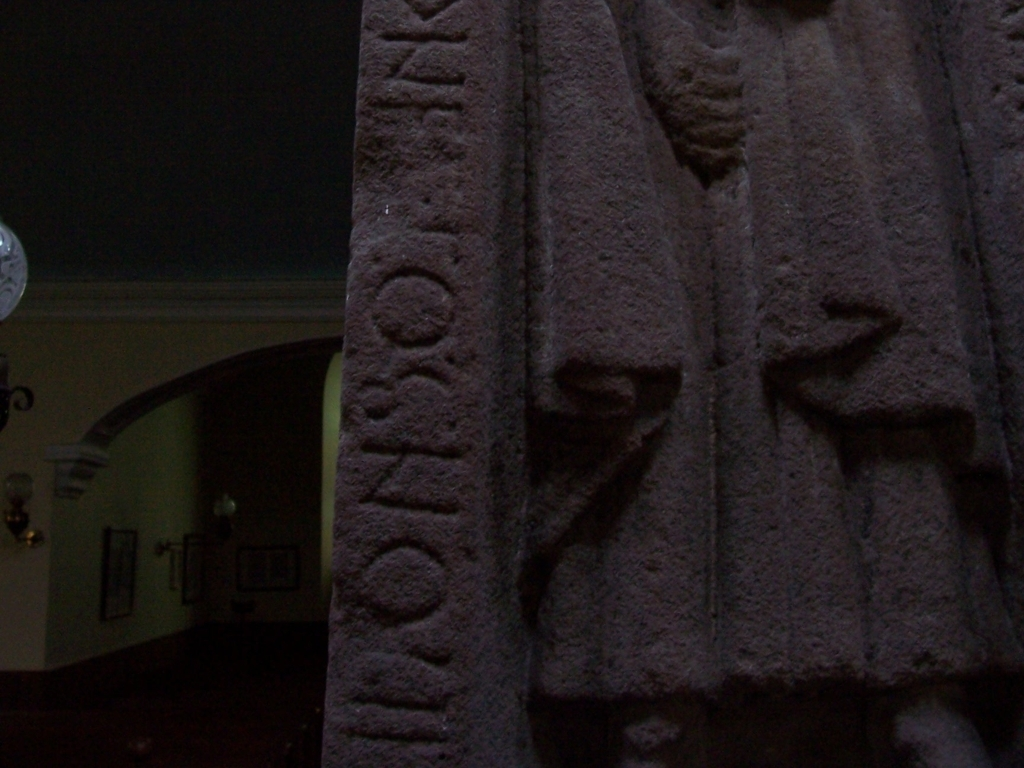Can you describe the object that appears to have inscriptions? The object in the image appears to be a stone artifact with carved inscriptions. The characters seem to be raised, possibly indicating an ancient or historical origin. The text is not fully visible, but it's clear that the craftsmanship is of significance, potentially offering insights into historical linguistics or cultural practices of a certain period. 